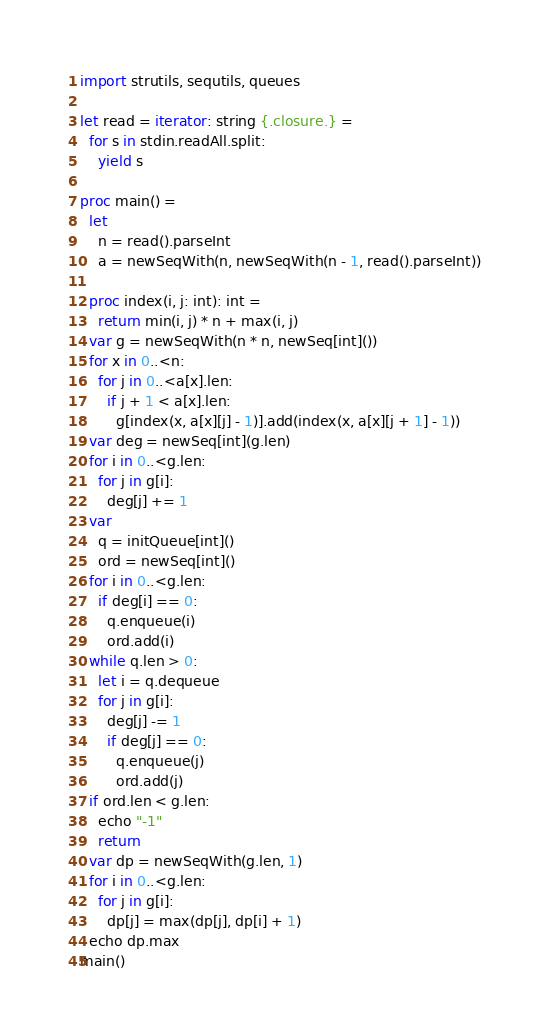Convert code to text. <code><loc_0><loc_0><loc_500><loc_500><_Nim_>import strutils, sequtils, queues

let read = iterator: string {.closure.} =
  for s in stdin.readAll.split:
    yield s

proc main() =
  let
    n = read().parseInt
    a = newSeqWith(n, newSeqWith(n - 1, read().parseInt))

  proc index(i, j: int): int =
    return min(i, j) * n + max(i, j)
  var g = newSeqWith(n * n, newSeq[int]())
  for x in 0..<n:
    for j in 0..<a[x].len:
      if j + 1 < a[x].len:
        g[index(x, a[x][j] - 1)].add(index(x, a[x][j + 1] - 1))
  var deg = newSeq[int](g.len)
  for i in 0..<g.len:
    for j in g[i]:
      deg[j] += 1
  var
    q = initQueue[int]()
    ord = newSeq[int]()
  for i in 0..<g.len:
    if deg[i] == 0:
      q.enqueue(i)
      ord.add(i)
  while q.len > 0:
    let i = q.dequeue
    for j in g[i]:
      deg[j] -= 1
      if deg[j] == 0:
        q.enqueue(j)
        ord.add(j)
  if ord.len < g.len:
    echo "-1"
    return
  var dp = newSeqWith(g.len, 1)
  for i in 0..<g.len:
    for j in g[i]:
      dp[j] = max(dp[j], dp[i] + 1)
  echo dp.max
main()
</code> 